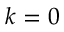<formula> <loc_0><loc_0><loc_500><loc_500>k = 0</formula> 